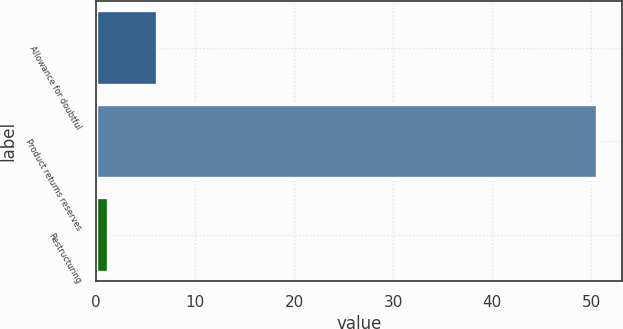Convert chart. <chart><loc_0><loc_0><loc_500><loc_500><bar_chart><fcel>Allowance for doubtful<fcel>Product returns reserves<fcel>Restructuring<nl><fcel>6.14<fcel>50.6<fcel>1.2<nl></chart> 